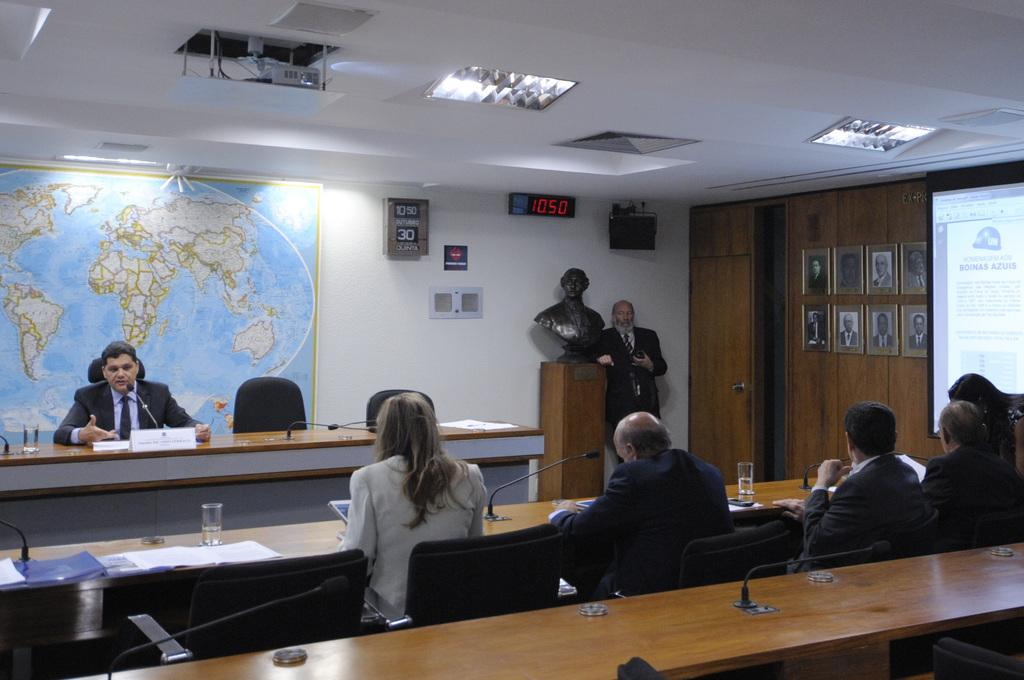What are the people in the image doing? The people in the image are sitting on chairs. Can you describe the man in the image? There is a man standing near a podium in the image. What is the aftermath of the event that took place in the image? There is no indication of an event or its aftermath in the image; it only shows people sitting on chairs and a man standing near a podium. 